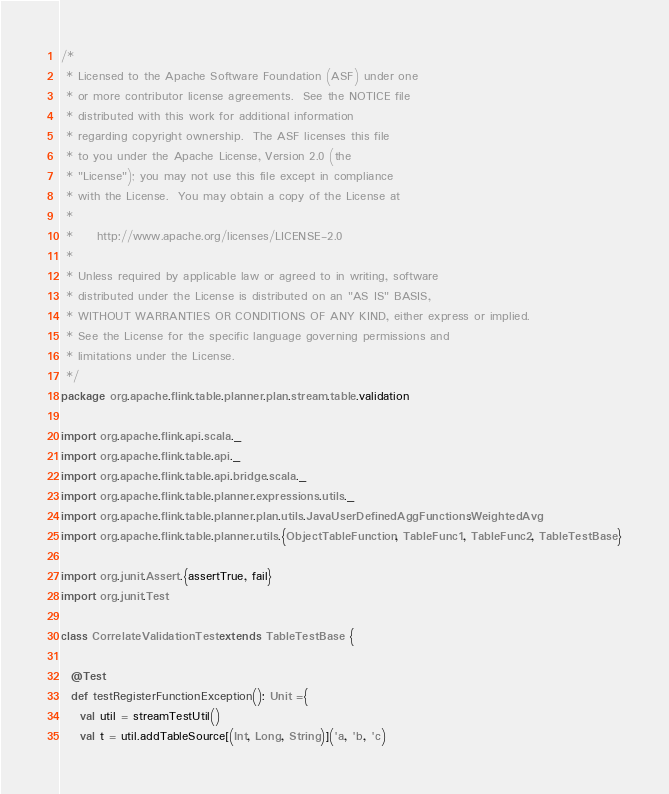<code> <loc_0><loc_0><loc_500><loc_500><_Scala_>/*
 * Licensed to the Apache Software Foundation (ASF) under one
 * or more contributor license agreements.  See the NOTICE file
 * distributed with this work for additional information
 * regarding copyright ownership.  The ASF licenses this file
 * to you under the Apache License, Version 2.0 (the
 * "License"); you may not use this file except in compliance
 * with the License.  You may obtain a copy of the License at
 *
 *     http://www.apache.org/licenses/LICENSE-2.0
 *
 * Unless required by applicable law or agreed to in writing, software
 * distributed under the License is distributed on an "AS IS" BASIS,
 * WITHOUT WARRANTIES OR CONDITIONS OF ANY KIND, either express or implied.
 * See the License for the specific language governing permissions and
 * limitations under the License.
 */
package org.apache.flink.table.planner.plan.stream.table.validation

import org.apache.flink.api.scala._
import org.apache.flink.table.api._
import org.apache.flink.table.api.bridge.scala._
import org.apache.flink.table.planner.expressions.utils._
import org.apache.flink.table.planner.plan.utils.JavaUserDefinedAggFunctions.WeightedAvg
import org.apache.flink.table.planner.utils.{ObjectTableFunction, TableFunc1, TableFunc2, TableTestBase}

import org.junit.Assert.{assertTrue, fail}
import org.junit.Test

class CorrelateValidationTest extends TableTestBase {

  @Test
  def testRegisterFunctionException(): Unit ={
    val util = streamTestUtil()
    val t = util.addTableSource[(Int, Long, String)]('a, 'b, 'c)
</code> 